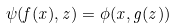Convert formula to latex. <formula><loc_0><loc_0><loc_500><loc_500>\psi ( f ( x ) , z ) = \phi ( x , g ( z ) )</formula> 